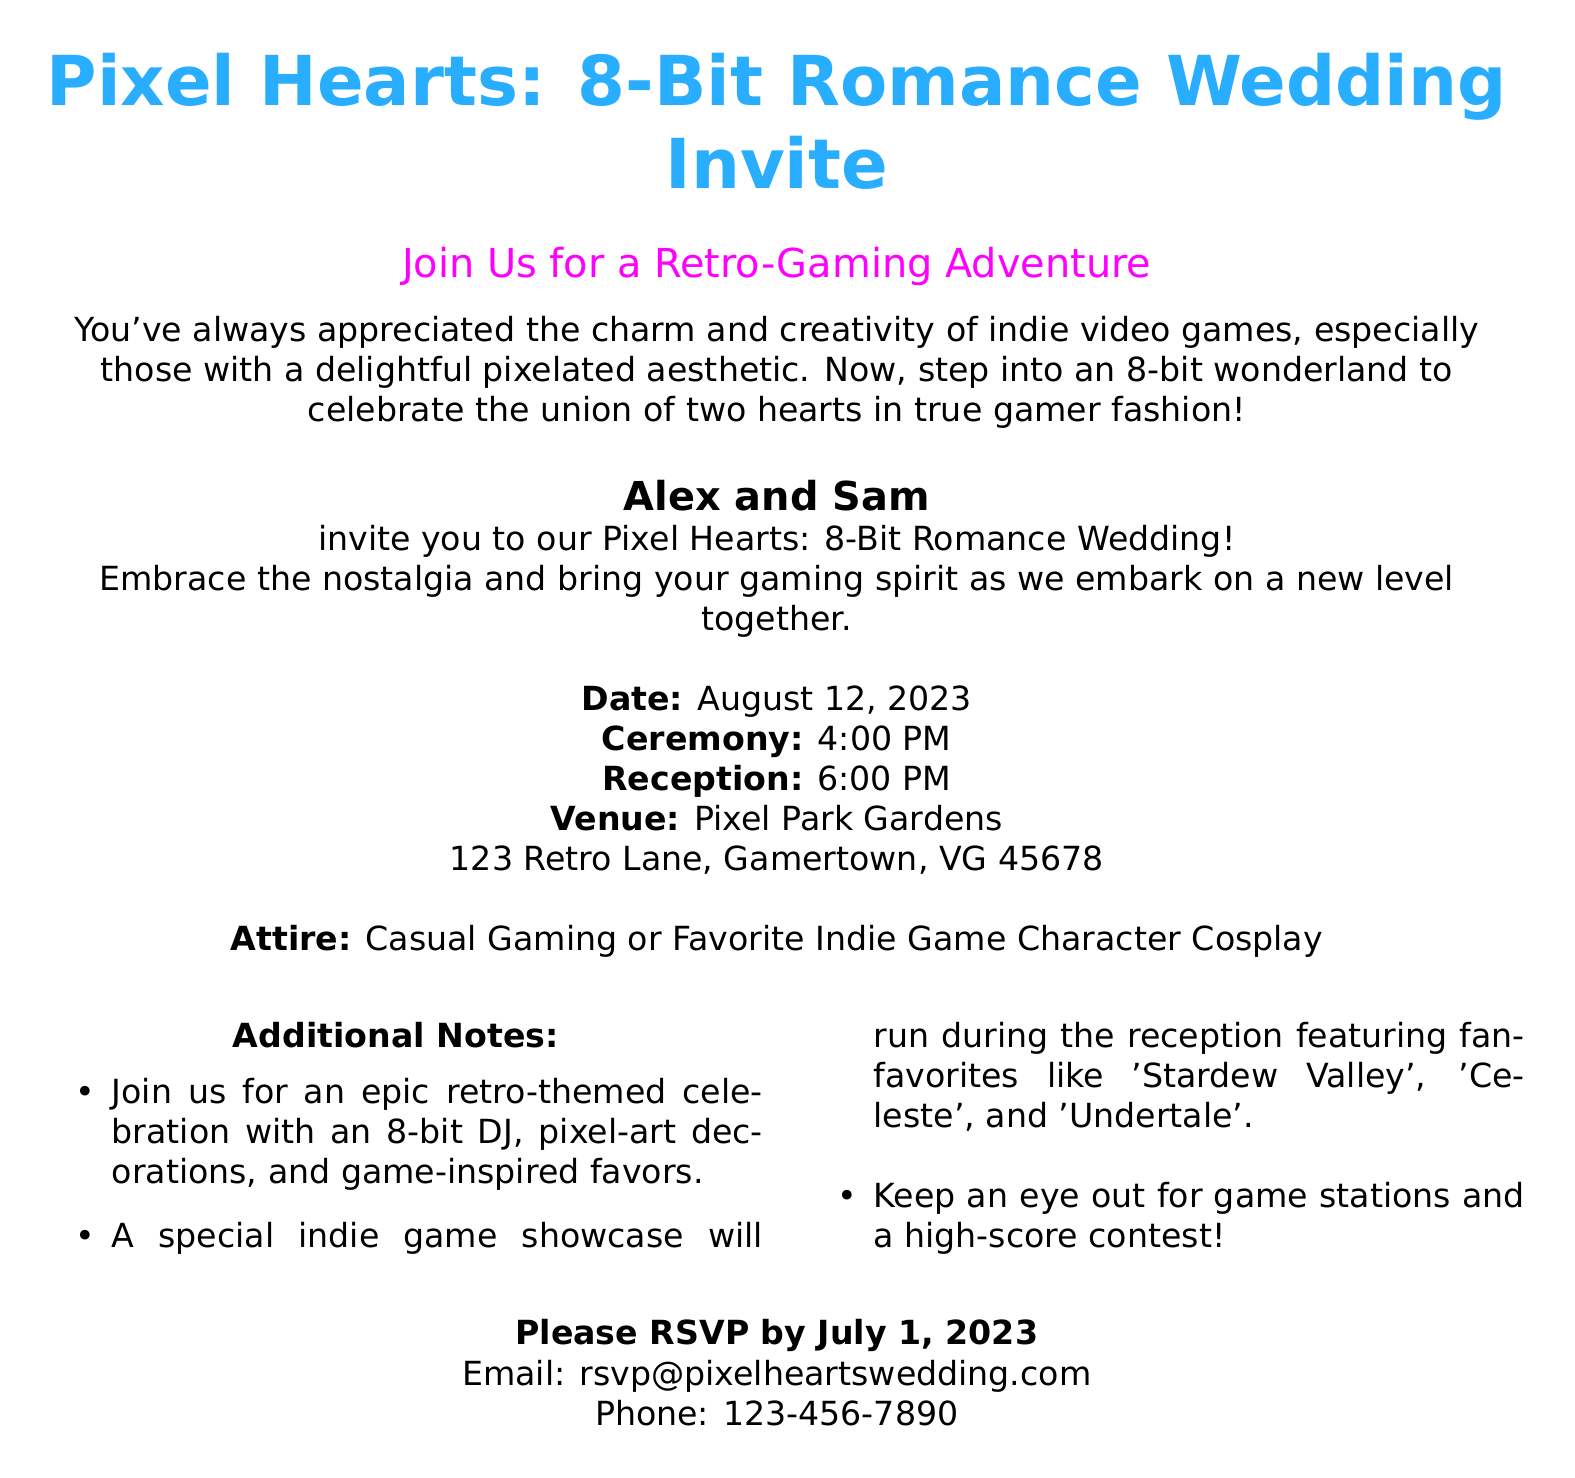What is the date of the wedding? The date of the wedding is explicitly stated in the document.
Answer: August 12, 2023 Who are the couple getting married? The names of the couple are mentioned in the invitation.
Answer: Alex and Sam What time does the reception start? The start time for the reception is provided in the document.
Answer: 6:00 PM What is the venue of the wedding? The name and address of the venue are listed within the invite.
Answer: Pixel Park Gardens, 123 Retro Lane, Gamertown, VG 45678 What type of attire is suggested? The recommended clothing style is specifically mentioned in the invitation.
Answer: Casual Gaming or Favorite Indie Game Character Cosplay What is one featured game during the reception? The document lists fan-favorite indie games that will be showcased.
Answer: Stardew Valley What is the RSVP deadline? The deadline for guests to respond is clearly outlined in the document.
Answer: July 1, 2023 How should guests RSVP? The invitation specifies the methods for guests to confirm their attendance.
Answer: Email or Phone 